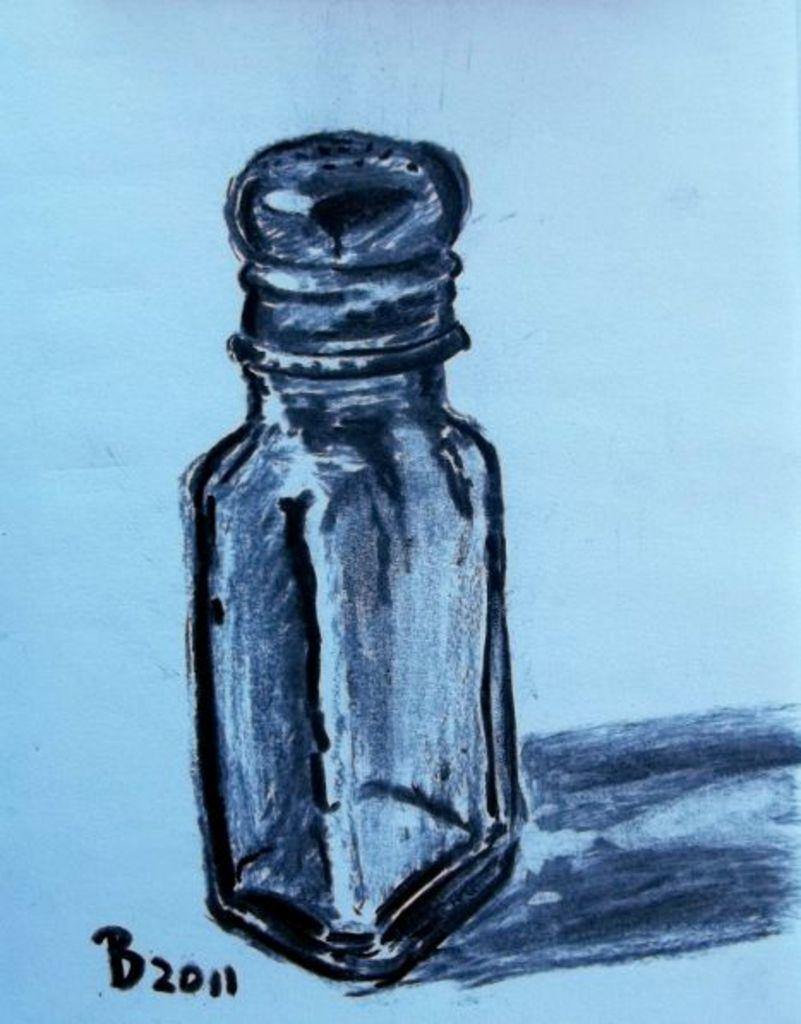When was the picture painted?
Provide a short and direct response. 2011. What year is on the picture?
Offer a terse response. 2011. 